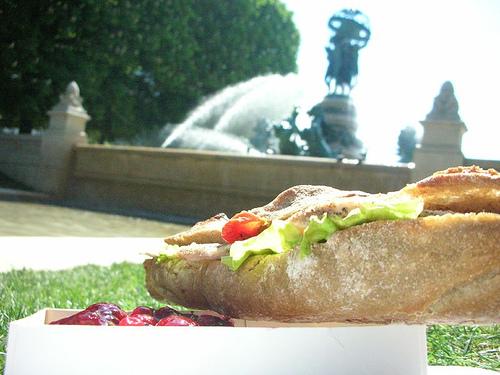Could this be at a fountain?
Give a very brief answer. Yes. What type of occasion could this be a picture of?
Be succinct. Picnic. How is the weather?
Concise answer only. Sunny. 